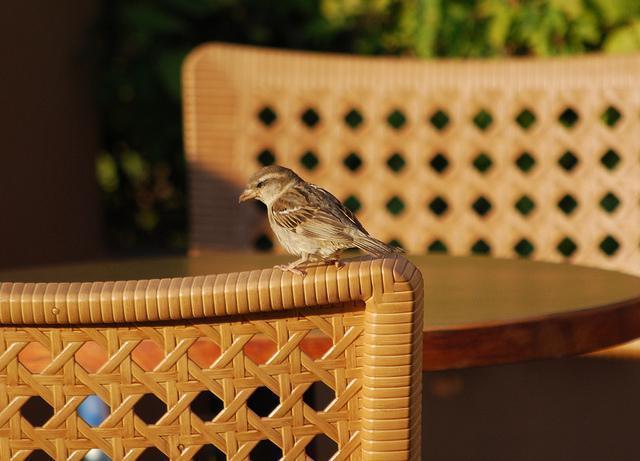How many chairs are there?
Give a very brief answer. 3. 